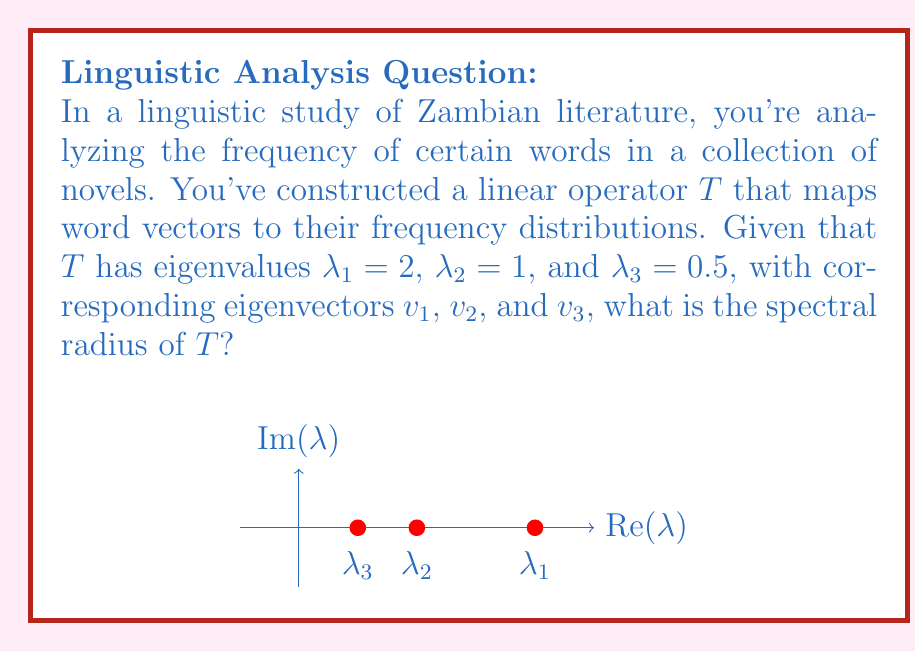Can you answer this question? Let's approach this step-by-step:

1) The spectral radius of a linear operator $T$, denoted as $\rho(T)$, is defined as:

   $$\rho(T) = \max\{|\lambda| : \lambda \text{ is an eigenvalue of } T\}$$

2) In this case, we have three eigenvalues:
   $\lambda_1 = 2$
   $\lambda_2 = 1$
   $\lambda_3 = 0.5$

3) To find the spectral radius, we need to calculate the absolute value of each eigenvalue:
   $|\lambda_1| = |2| = 2$
   $|\lambda_2| = |1| = 1$
   $|\lambda_3| = |0.5| = 0.5$

4) Now, we need to find the maximum of these absolute values:
   $$\max\{2, 1, 0.5\} = 2$$

5) Therefore, the spectral radius of $T$ is 2.

This result tells us that the operator $T$ will, at most, double the magnitude of any input vector in the long run when applied repeatedly. In the context of word frequency analysis, this suggests that the most significant word patterns in the Zambian literature being studied can have up to twice the impact on the frequency distribution compared to the average word.
Answer: $\rho(T) = 2$ 